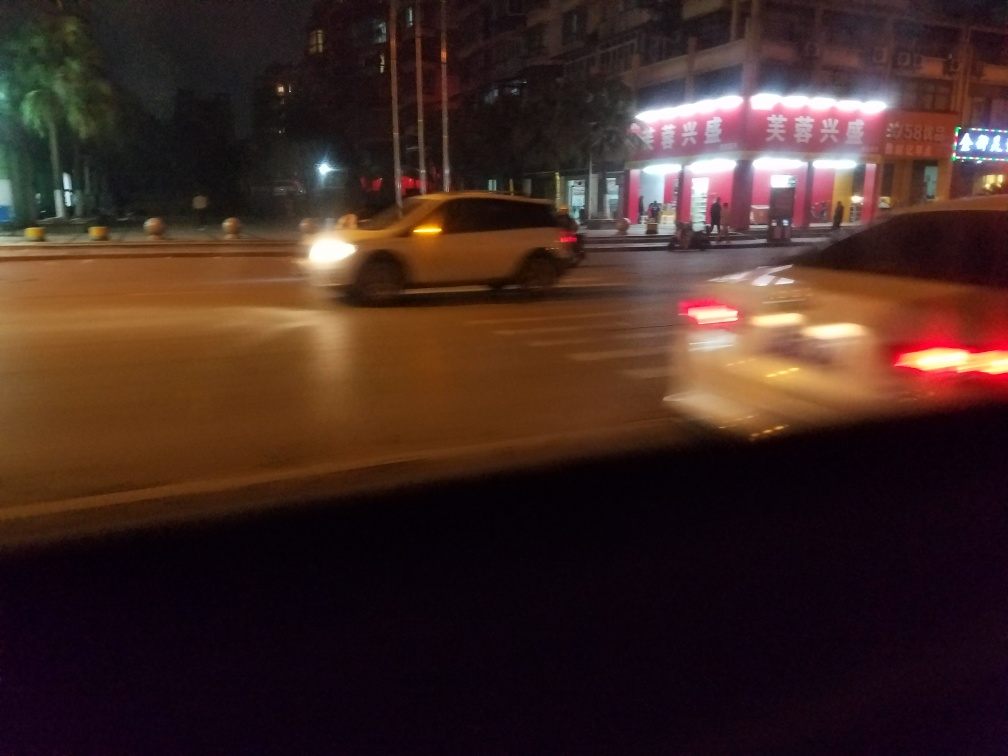Is the background sharp? No, the background is not sharp. The image shows motion blur, particularly noticeable in the moving vehicles and somewhat in the stationary background as well, such as the text on the buildings and the palm trees. The slight blur suggests the photo was taken with a slower shutter speed or while the camera was in motion. 